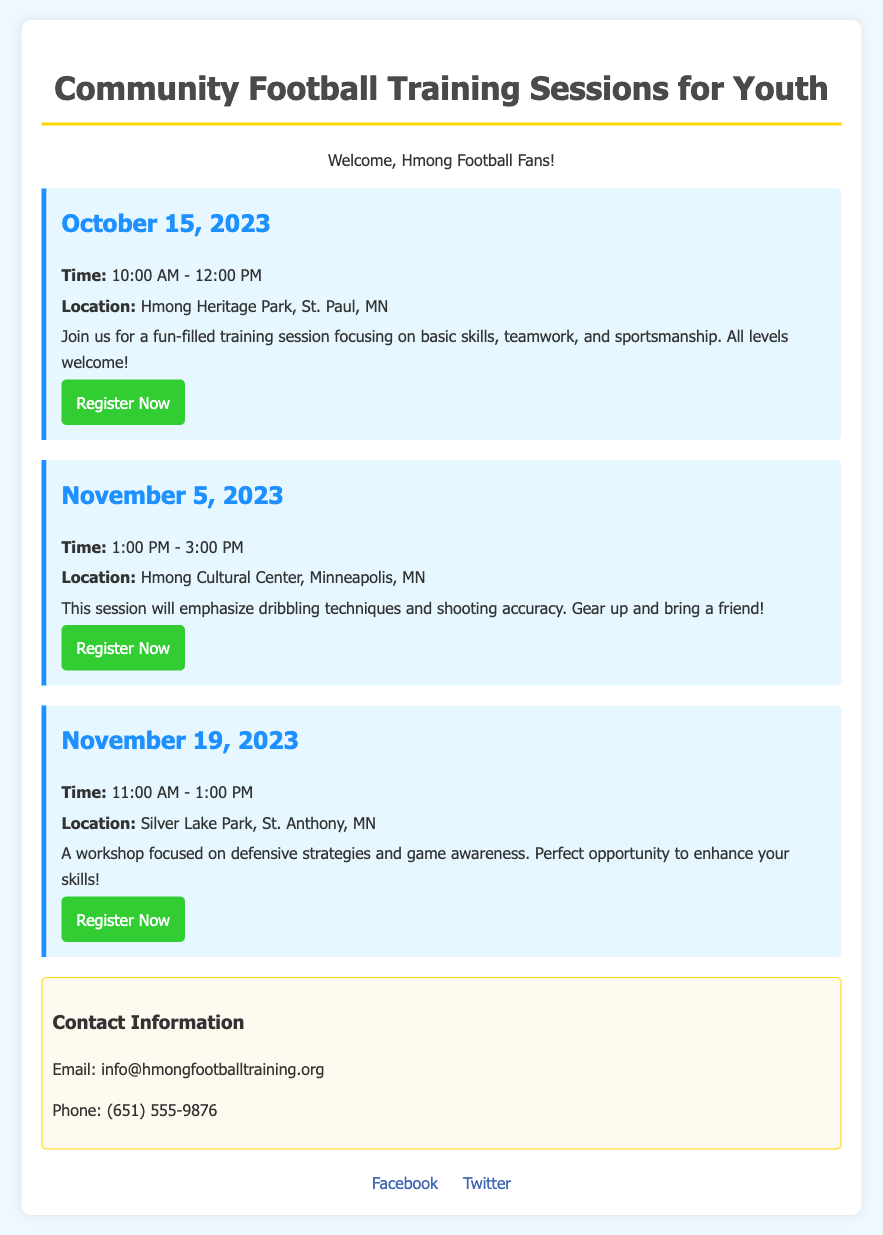What is the date of the first training session? The first training session is on October 15, 2023, as indicated in the document.
Answer: October 15, 2023 Where is the October 15 session taking place? The location for the October 15 session is specified as Hmong Heritage Park, St. Paul, MN.
Answer: Hmong Heritage Park, St. Paul, MN What is the focus of the November 5 training session? The document states that the focus for the November 5 session is on dribbling techniques and shooting accuracy.
Answer: Dribbling techniques and shooting accuracy What time does the session on November 19 start? The starting time for the session on November 19 is clearly mentioned as 11:00 AM.
Answer: 11:00 AM Which session emphasizes defensive strategies? The session that emphasizes defensive strategies is the one scheduled for November 19.
Answer: November 19 How many total training sessions are listed in the document? The document lists a total of three training sessions available for youth.
Answer: Three What should participants bring to the November 5 session? Attendees are encouraged to bring a friend, according to the details provided for the November 5 session.
Answer: A friend What is the registration URL for the October 15 session? The registration URL for the October 15 session is indicated in the document, linking to the relevant sign-up page.
Answer: https://www.hmongfootballtraining.org/register-oct15 What is the email contact provided in the document? The document provides the email contact for inquiries as info@hmongfootballtraining.org.
Answer: info@hmongfootballtraining.org 